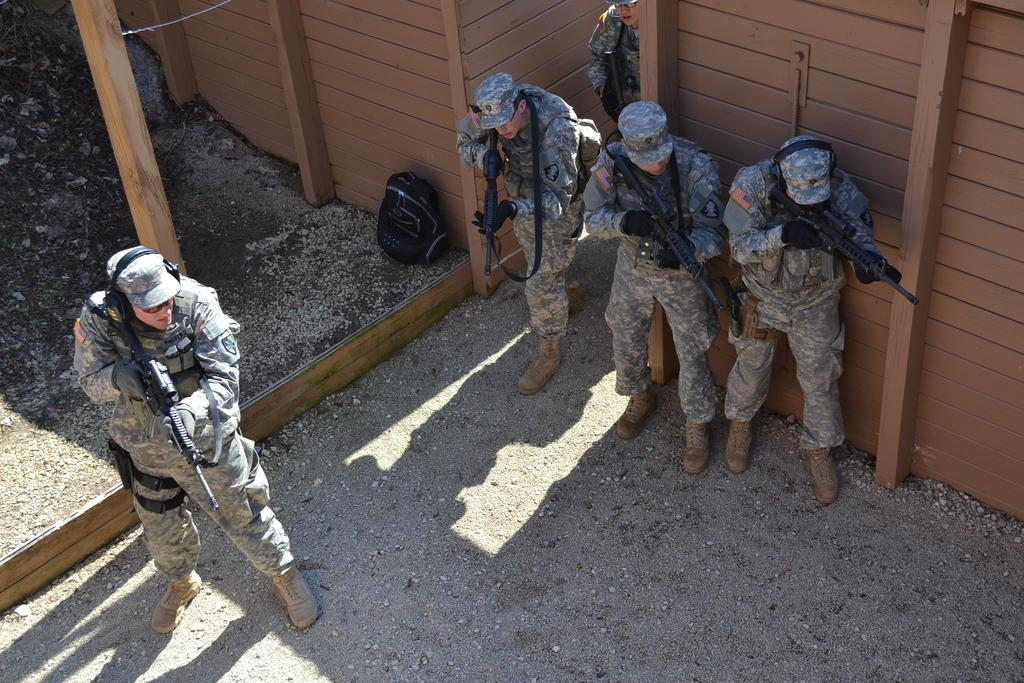How many people are in the image? There are people in the image, but the exact number is not specified. What is the location of the people in the image? The people are standing on the land in the image. What are the people holding in the image? The people are holding guns in the image. What object can be seen on the land in the image? There is a bag on the land in the image. What type of structure is visible in the image? There is a wooden wall in the image. What is the reason for the minute comparison between the two objects in the image? There is no mention of a comparison between two objects in the image, so this question cannot be answered definitively. 